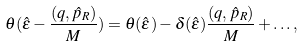<formula> <loc_0><loc_0><loc_500><loc_500>\theta ( \hat { \epsilon } - \frac { ( { q } , { \hat { p } } _ { R } ) } { M } ) = \theta ( \hat { \epsilon } ) - \delta ( \hat { \epsilon } ) \frac { ( { q } , { \hat { p } } _ { R } ) } { M } + \dots ,</formula> 